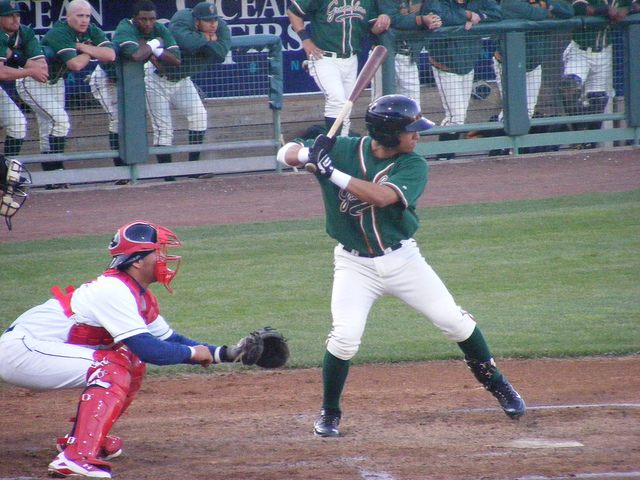<image>What kind of ball is the man holding? The man is not holding a ball. However, it could be a baseball if there was one. What kind of ball is the man holding? The man is not holding any ball. 